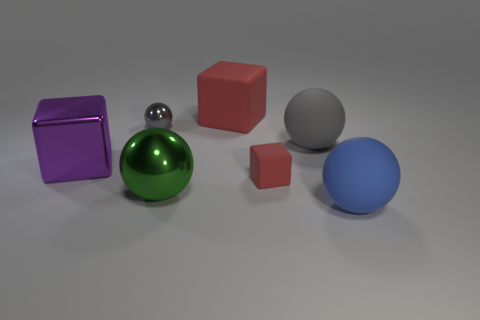What materials do the objects in the image seem to be made of? The objects in the image appear to exhibit various materials. The large red and smaller red cubes, along with the small gray cube, seem to have a matte finish typical of plastic or painted wood. The green sphere has a reflective metallic finish, suggesting it could be made of polished metal or coated in a metallic paint, whereas the large purple cube looks to have a glossy, possibly glassy surface. Lastly, the sphere on the far right appears to have a smooth, opaque finish, consistent with rubber or matte plastic. 